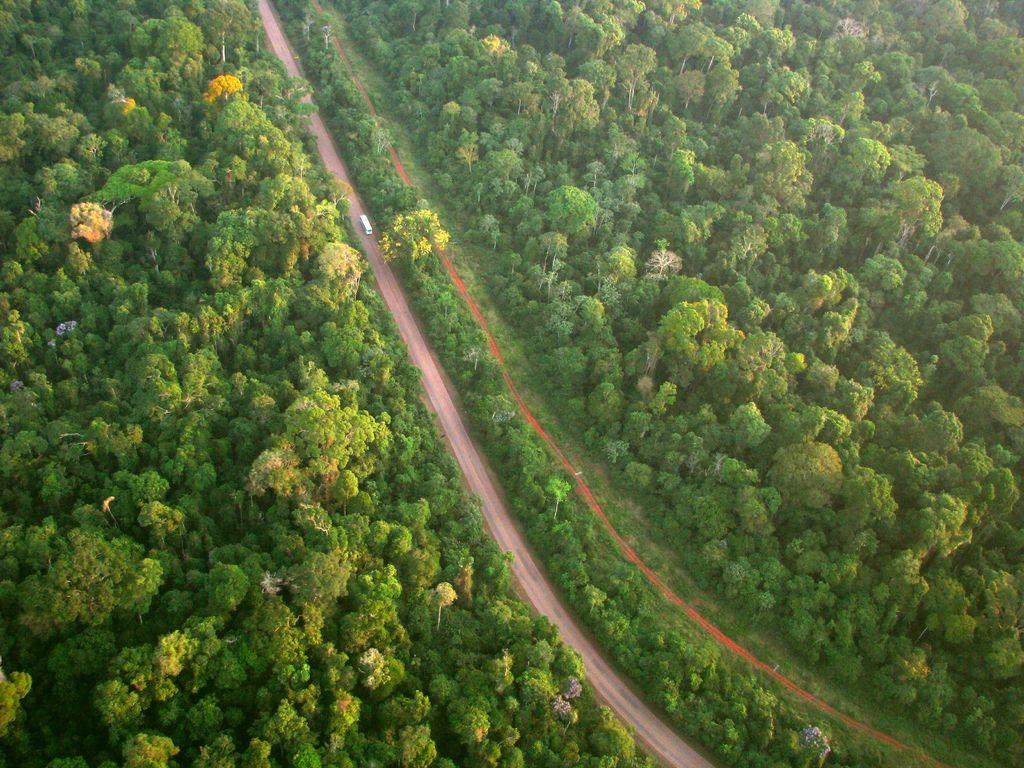What is the main feature in the center of the image? There is a road in the center of the image. What can be seen on the road? A white-colored vehicle is on the road. What type of vegetation is present on both sides of the road? There are trees on both sides of the road. What type of underwear is hanging on the trees in the image? There is no underwear present in the image; only a road, a white-colored vehicle, and trees are visible. 